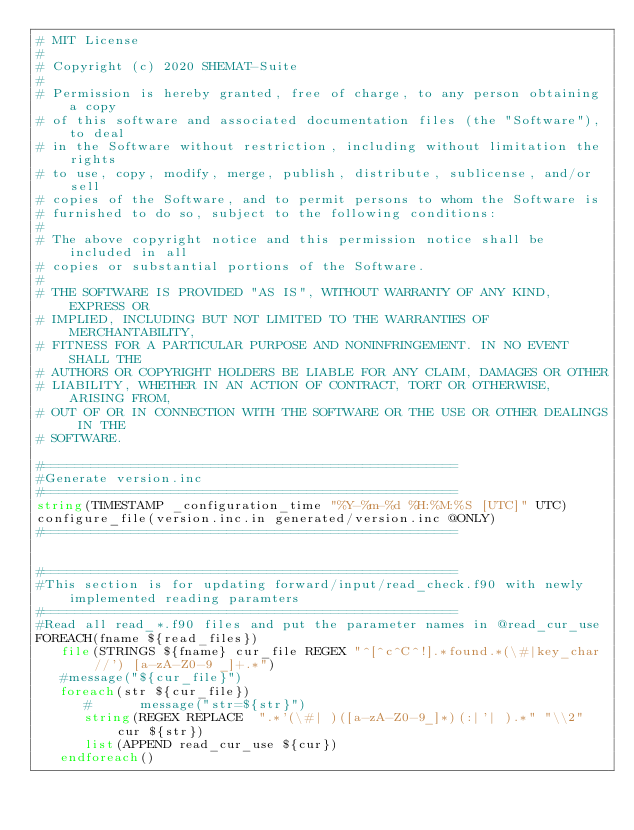<code> <loc_0><loc_0><loc_500><loc_500><_CMake_># MIT License
#
# Copyright (c) 2020 SHEMAT-Suite
#
# Permission is hereby granted, free of charge, to any person obtaining a copy
# of this software and associated documentation files (the "Software"), to deal
# in the Software without restriction, including without limitation the rights
# to use, copy, modify, merge, publish, distribute, sublicense, and/or sell
# copies of the Software, and to permit persons to whom the Software is
# furnished to do so, subject to the following conditions:
#
# The above copyright notice and this permission notice shall be included in all
# copies or substantial portions of the Software.
#
# THE SOFTWARE IS PROVIDED "AS IS", WITHOUT WARRANTY OF ANY KIND, EXPRESS OR
# IMPLIED, INCLUDING BUT NOT LIMITED TO THE WARRANTIES OF MERCHANTABILITY,
# FITNESS FOR A PARTICULAR PURPOSE AND NONINFRINGEMENT. IN NO EVENT SHALL THE
# AUTHORS OR COPYRIGHT HOLDERS BE LIABLE FOR ANY CLAIM, DAMAGES OR OTHER
# LIABILITY, WHETHER IN AN ACTION OF CONTRACT, TORT OR OTHERWISE, ARISING FROM,
# OUT OF OR IN CONNECTION WITH THE SOFTWARE OR THE USE OR OTHER DEALINGS IN THE
# SOFTWARE.

#====================================================
#Generate version.inc
#====================================================
string(TIMESTAMP _configuration_time "%Y-%m-%d %H:%M:%S [UTC]" UTC)
configure_file(version.inc.in generated/version.inc @ONLY)
#====================================================


#====================================================
#This section is for updating forward/input/read_check.f90 with newly implemented reading paramters
#====================================================
#Read all read_*.f90 files and put the parameter names in @read_cur_use
FOREACH(fname ${read_files})
   file(STRINGS ${fname} cur_file REGEX "^[^c^C^!].*found.*(\#|key_char//') [a-zA-Z0-9 _]+.*")
   #message("${cur_file}")
   foreach(str ${cur_file})
      #      message("str=${str}")
      string(REGEX REPLACE  ".*'(\#| )([a-zA-Z0-9_]*)(:|'| ).*" "\\2" cur ${str})
      list(APPEND read_cur_use ${cur})
   endforeach()</code> 